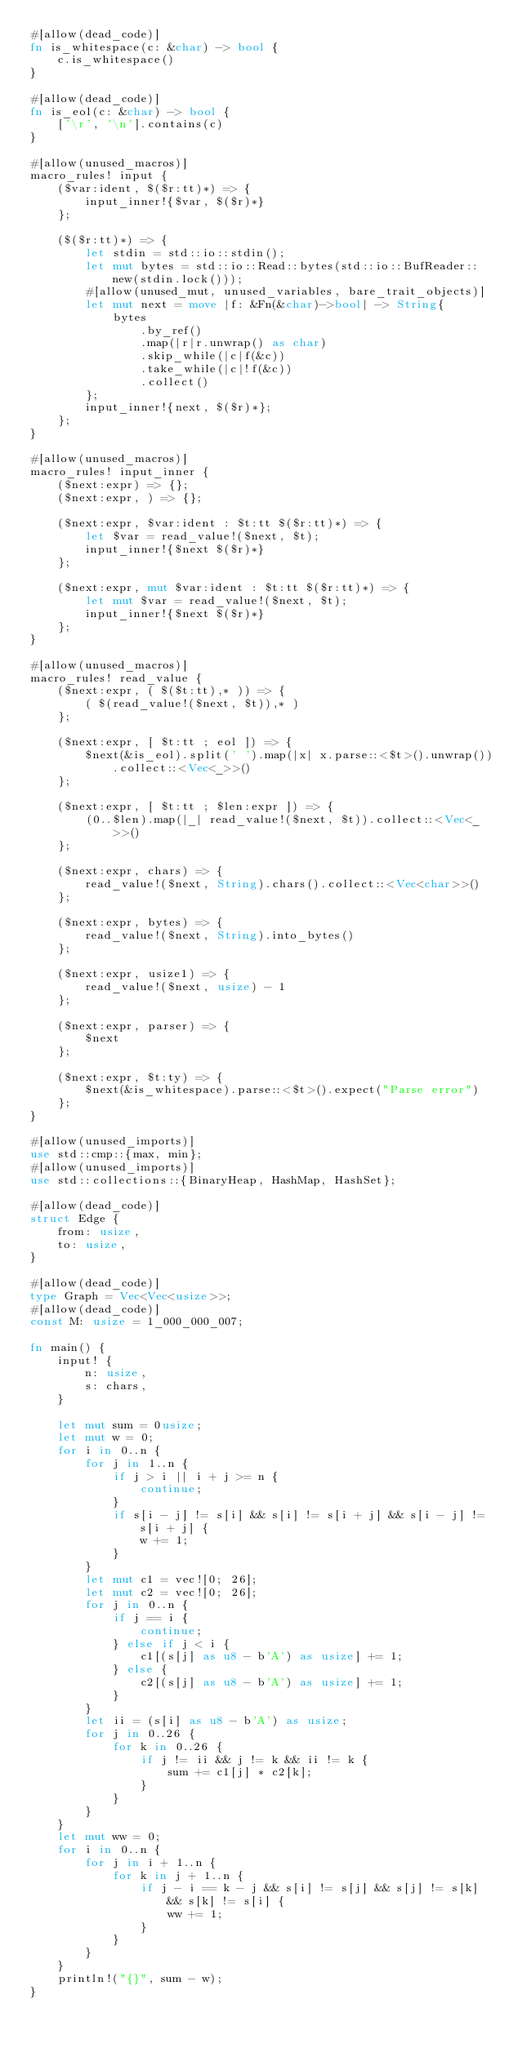Convert code to text. <code><loc_0><loc_0><loc_500><loc_500><_Rust_>#[allow(dead_code)]
fn is_whitespace(c: &char) -> bool {
    c.is_whitespace()
}

#[allow(dead_code)]
fn is_eol(c: &char) -> bool {
    ['\r', '\n'].contains(c)
}

#[allow(unused_macros)]
macro_rules! input {
    ($var:ident, $($r:tt)*) => {
        input_inner!{$var, $($r)*}
    };

    ($($r:tt)*) => {
        let stdin = std::io::stdin();
        let mut bytes = std::io::Read::bytes(std::io::BufReader::new(stdin.lock()));
        #[allow(unused_mut, unused_variables, bare_trait_objects)]
        let mut next = move |f: &Fn(&char)->bool| -> String{
            bytes
                .by_ref()
                .map(|r|r.unwrap() as char)
                .skip_while(|c|f(&c))
                .take_while(|c|!f(&c))
                .collect()
        };
        input_inner!{next, $($r)*};
    };
}

#[allow(unused_macros)]
macro_rules! input_inner {
    ($next:expr) => {};
    ($next:expr, ) => {};

    ($next:expr, $var:ident : $t:tt $($r:tt)*) => {
        let $var = read_value!($next, $t);
        input_inner!{$next $($r)*}
    };

    ($next:expr, mut $var:ident : $t:tt $($r:tt)*) => {
        let mut $var = read_value!($next, $t);
        input_inner!{$next $($r)*}
    };
}

#[allow(unused_macros)]
macro_rules! read_value {
    ($next:expr, ( $($t:tt),* )) => {
        ( $(read_value!($next, $t)),* )
    };

    ($next:expr, [ $t:tt ; eol ]) => {
        $next(&is_eol).split(' ').map(|x| x.parse::<$t>().unwrap()).collect::<Vec<_>>()
    };

    ($next:expr, [ $t:tt ; $len:expr ]) => {
        (0..$len).map(|_| read_value!($next, $t)).collect::<Vec<_>>()
    };

    ($next:expr, chars) => {
        read_value!($next, String).chars().collect::<Vec<char>>()
    };

    ($next:expr, bytes) => {
        read_value!($next, String).into_bytes()
    };

    ($next:expr, usize1) => {
        read_value!($next, usize) - 1
    };

    ($next:expr, parser) => {
        $next
    };

    ($next:expr, $t:ty) => {
        $next(&is_whitespace).parse::<$t>().expect("Parse error")
    };
}

#[allow(unused_imports)]
use std::cmp::{max, min};
#[allow(unused_imports)]
use std::collections::{BinaryHeap, HashMap, HashSet};

#[allow(dead_code)]
struct Edge {
    from: usize,
    to: usize,
}

#[allow(dead_code)]
type Graph = Vec<Vec<usize>>;
#[allow(dead_code)]
const M: usize = 1_000_000_007;

fn main() {
    input! {
        n: usize,
        s: chars,
    }

    let mut sum = 0usize;
    let mut w = 0;
    for i in 0..n {
        for j in 1..n {
            if j > i || i + j >= n {
                continue;
            }
            if s[i - j] != s[i] && s[i] != s[i + j] && s[i - j] != s[i + j] {
                w += 1;
            }
        }
        let mut c1 = vec![0; 26];
        let mut c2 = vec![0; 26];
        for j in 0..n {
            if j == i {
                continue;
            } else if j < i {
                c1[(s[j] as u8 - b'A') as usize] += 1;
            } else {
                c2[(s[j] as u8 - b'A') as usize] += 1;
            }
        }
        let ii = (s[i] as u8 - b'A') as usize;
        for j in 0..26 {
            for k in 0..26 {
                if j != ii && j != k && ii != k {
                    sum += c1[j] * c2[k];
                }
            }
        }
    }
    let mut ww = 0;
    for i in 0..n {
        for j in i + 1..n {
            for k in j + 1..n {
                if j - i == k - j && s[i] != s[j] && s[j] != s[k] && s[k] != s[i] {
                    ww += 1;
                }
            }
        }
    }
    println!("{}", sum - w);
}
</code> 